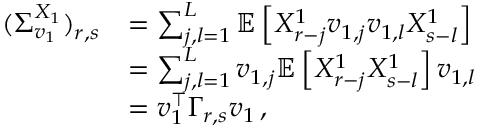Convert formula to latex. <formula><loc_0><loc_0><loc_500><loc_500>\begin{array} { r l } { ( \Sigma _ { v _ { 1 } } ^ { X _ { 1 } } ) _ { r , s } } & { = \sum _ { j , l = 1 } ^ { L } \mathbb { E } \left [ X _ { r - j } ^ { 1 } v _ { 1 , j } v _ { 1 , l } X _ { s - l } ^ { 1 } \right ] } \\ & { = \sum _ { j , l = 1 } ^ { L } v _ { 1 , j } \mathbb { E } \left [ X _ { r - j } ^ { 1 } X _ { s - l } ^ { 1 } \right ] v _ { 1 , l } } \\ & { = v _ { 1 } ^ { \top } \Gamma _ { r , s } v _ { 1 } \, , } \end{array}</formula> 